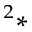<formula> <loc_0><loc_0><loc_500><loc_500>^ { 2 } \ast</formula> 